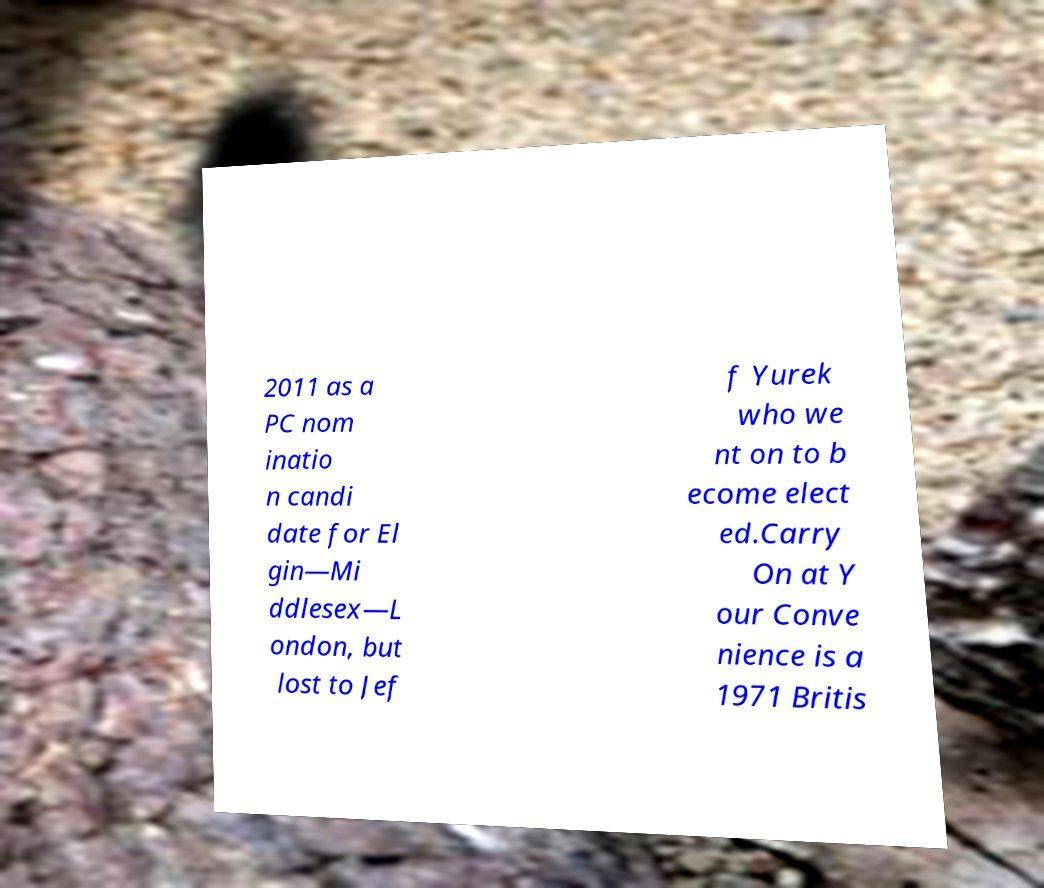Could you extract and type out the text from this image? 2011 as a PC nom inatio n candi date for El gin—Mi ddlesex—L ondon, but lost to Jef f Yurek who we nt on to b ecome elect ed.Carry On at Y our Conve nience is a 1971 Britis 